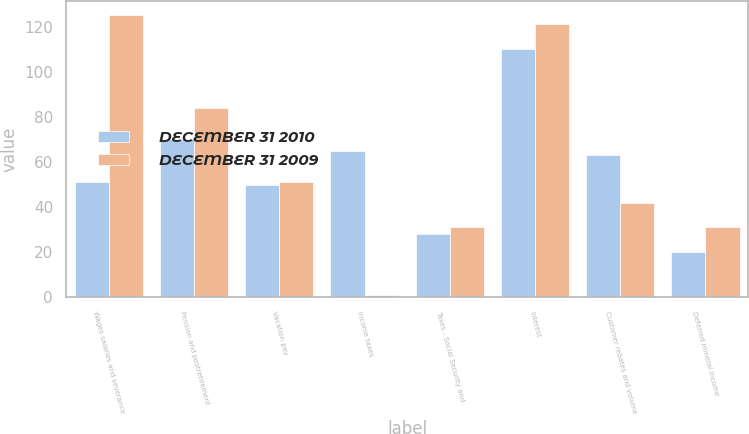Convert chart. <chart><loc_0><loc_0><loc_500><loc_500><stacked_bar_chart><ecel><fcel>Wages salaries and severance<fcel>Pension and postretirement<fcel>Vacation pay<fcel>Income taxes<fcel>Taxes - Social Security and<fcel>Interest<fcel>Customer rebates and volume<fcel>Deferred mineral income<nl><fcel>DECEMBER 31 2010<fcel>51<fcel>70<fcel>50<fcel>65<fcel>28<fcel>110<fcel>63<fcel>20<nl><fcel>DECEMBER 31 2009<fcel>125<fcel>84<fcel>51<fcel>1<fcel>31<fcel>121<fcel>42<fcel>31<nl></chart> 